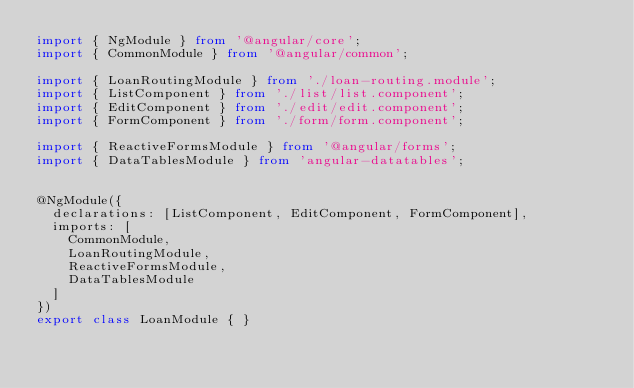Convert code to text. <code><loc_0><loc_0><loc_500><loc_500><_TypeScript_>import { NgModule } from '@angular/core';
import { CommonModule } from '@angular/common';

import { LoanRoutingModule } from './loan-routing.module';
import { ListComponent } from './list/list.component';
import { EditComponent } from './edit/edit.component';
import { FormComponent } from './form/form.component';

import { ReactiveFormsModule } from '@angular/forms';
import { DataTablesModule } from 'angular-datatables';


@NgModule({
  declarations: [ListComponent, EditComponent, FormComponent],
  imports: [
    CommonModule,
    LoanRoutingModule,
    ReactiveFormsModule,
    DataTablesModule
  ]
})
export class LoanModule { }
</code> 